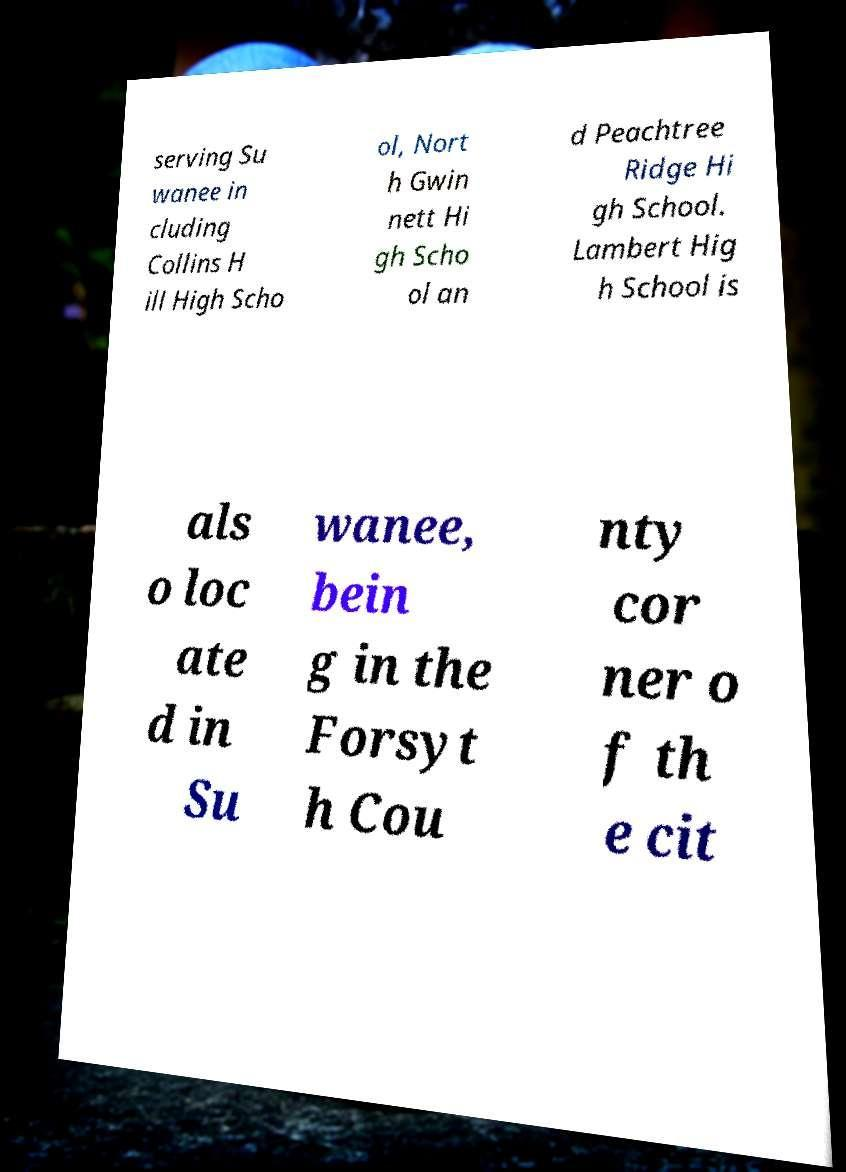Please read and relay the text visible in this image. What does it say? serving Su wanee in cluding Collins H ill High Scho ol, Nort h Gwin nett Hi gh Scho ol an d Peachtree Ridge Hi gh School. Lambert Hig h School is als o loc ate d in Su wanee, bein g in the Forsyt h Cou nty cor ner o f th e cit 